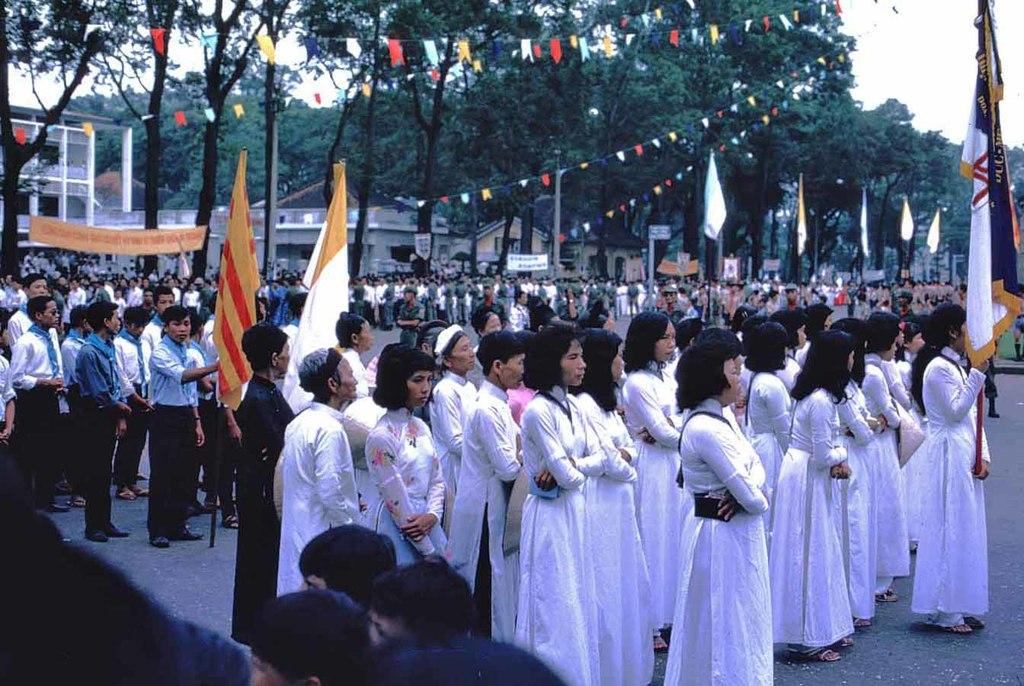What is the main subject of the image? The main subject of the image is a crowd. What are the people in the crowd holding? The people in the crowd are holding flags. What other objects can be seen in the image besides the crowd and flags? There are poles, boards, trees, buildings, and the sky visible in the image. Can you see any smoke coming from the tooth in the image? There is no tooth or smoke present in the image. What type of home is visible in the image? There is no home visible in the image; it features a crowd, flags, poles, boards, trees, buildings, and the sky. 